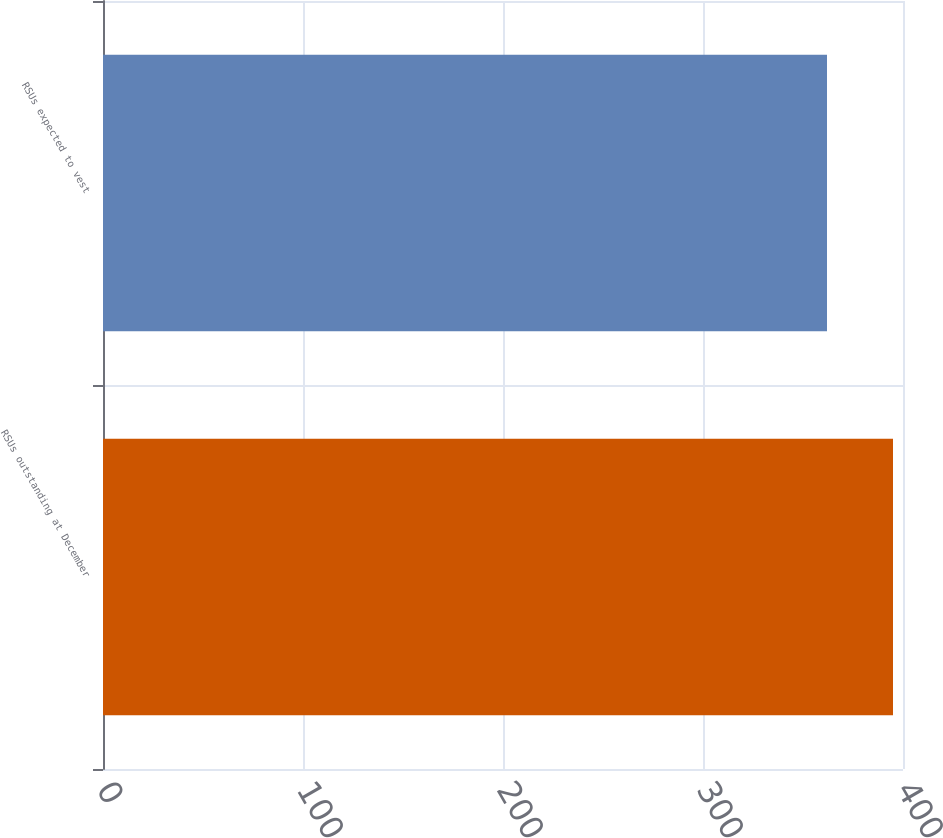<chart> <loc_0><loc_0><loc_500><loc_500><bar_chart><fcel>RSUs outstanding at December<fcel>RSUs expected to vest<nl><fcel>395<fcel>362<nl></chart> 